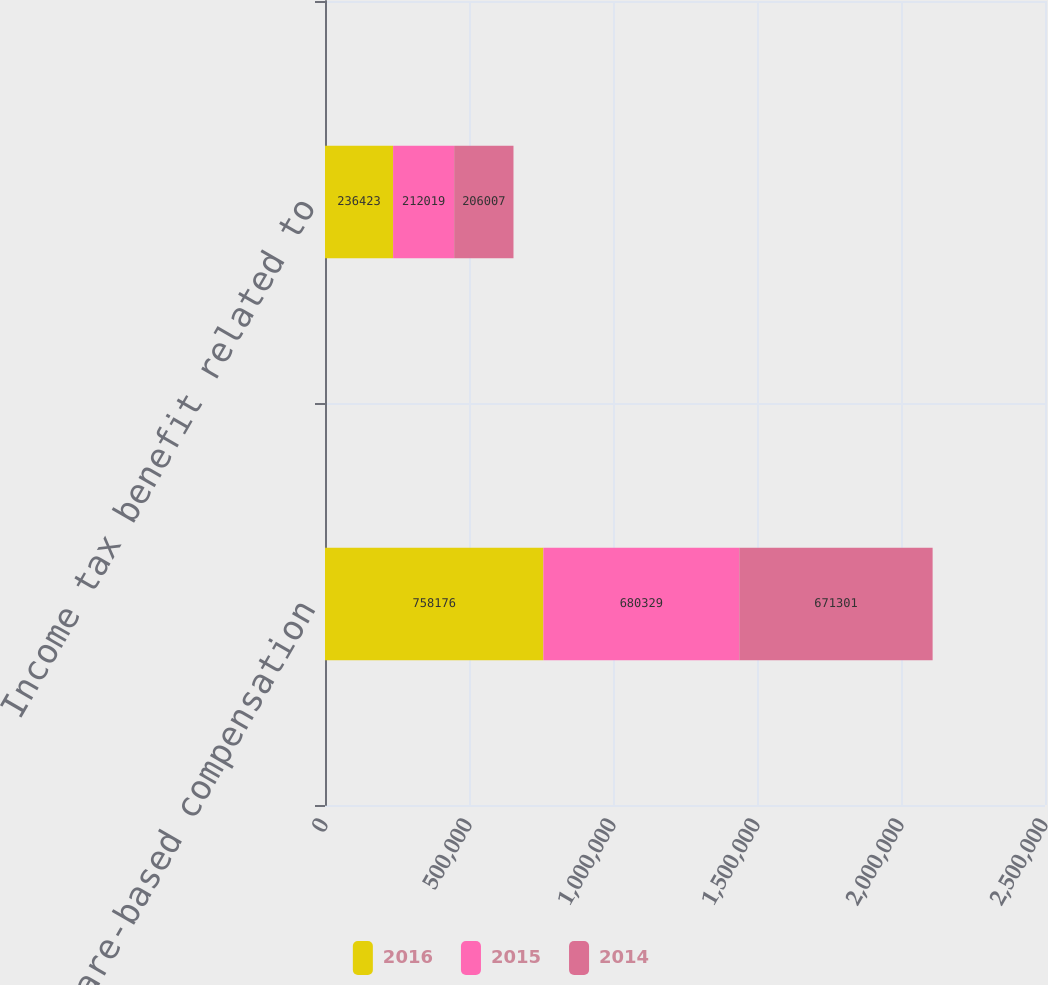Convert chart to OTSL. <chart><loc_0><loc_0><loc_500><loc_500><stacked_bar_chart><ecel><fcel>Total share-based compensation<fcel>Income tax benefit related to<nl><fcel>2016<fcel>758176<fcel>236423<nl><fcel>2015<fcel>680329<fcel>212019<nl><fcel>2014<fcel>671301<fcel>206007<nl></chart> 